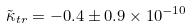<formula> <loc_0><loc_0><loc_500><loc_500>\tilde { \kappa } _ { t r } = - 0 . 4 \pm 0 . 9 \times 1 0 ^ { - 1 0 }</formula> 